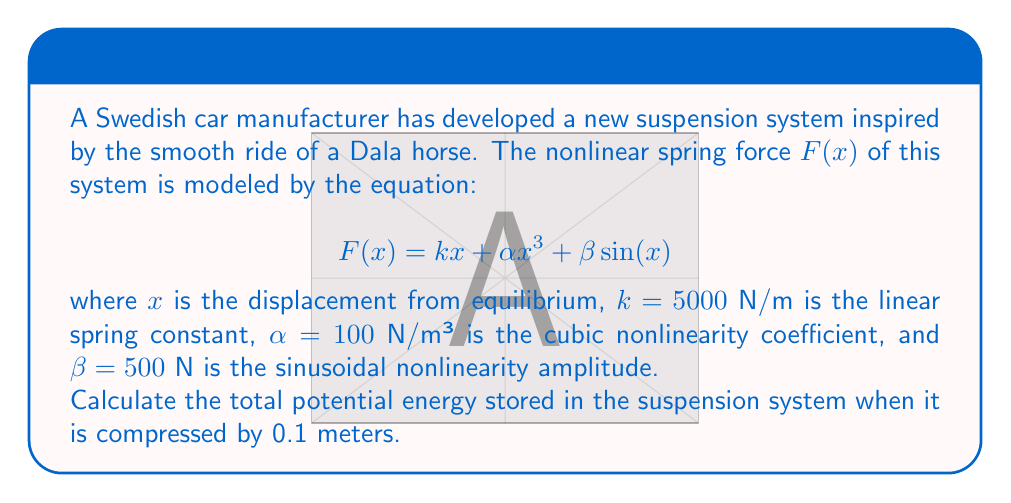Could you help me with this problem? To solve this problem, we need to follow these steps:

1) The potential energy $U(x)$ is given by the integral of the force function:

   $$U(x) = \int_0^x F(s) ds$$

2) Substituting our force function:

   $$U(x) = \int_0^x (ks + \alpha s^3 + \beta \sin(s)) ds$$

3) Integrate each term separately:

   $$U(x) = [\frac{1}{2}ks^2]_0^x + [\frac{1}{4}\alpha s^4]_0^x + [-\beta \cos(s)]_0^x$$

4) Evaluate the integral:

   $$U(x) = \frac{1}{2}kx^2 + \frac{1}{4}\alpha x^4 - \beta (\cos(x) - 1)$$

5) Now, substitute the given values: $k = 5000$, $\alpha = 100$, $\beta = 500$, and $x = 0.1$:

   $$U(0.1) = \frac{1}{2}(5000)(0.1)^2 + \frac{1}{4}(100)(0.1)^4 - 500(\cos(0.1) - 1)$$

6) Calculate each term:
   - $\frac{1}{2}(5000)(0.1)^2 = 25$ J
   - $\frac{1}{4}(100)(0.1)^4 = 0.000025$ J
   - $500(\cos(0.1) - 1) \approx -2.4988$ J

7) Sum up all terms:

   $$U(0.1) = 25 + 0.000025 + 2.4988 = 27.4988 \text{ J}$$
Answer: 27.4988 J 